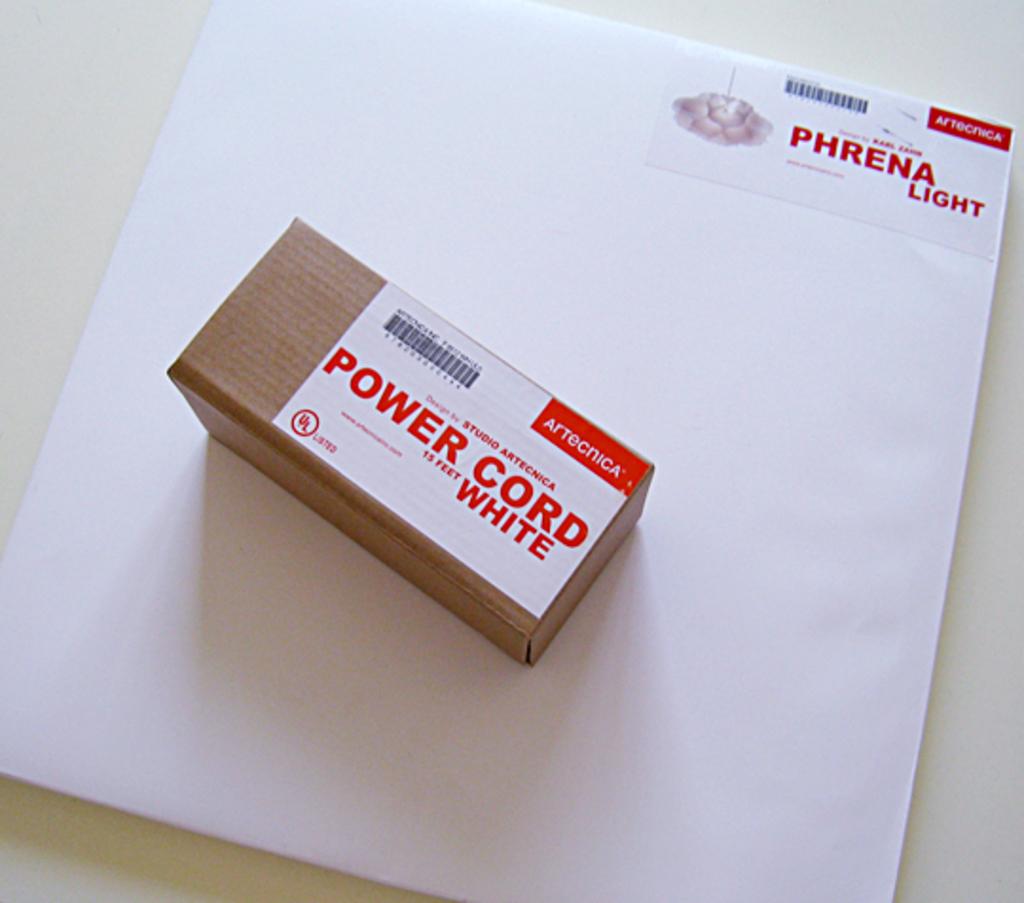What is in this box?
Give a very brief answer. Power cord. White power cord?
Ensure brevity in your answer.  Yes. 